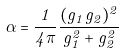Convert formula to latex. <formula><loc_0><loc_0><loc_500><loc_500>\alpha = \frac { 1 } { 4 \pi } \frac { ( g _ { 1 } g _ { 2 } ) ^ { 2 } } { g _ { 1 } ^ { 2 } + g _ { 2 } ^ { 2 } }</formula> 